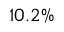Convert formula to latex. <formula><loc_0><loc_0><loc_500><loc_500>1 0 . 2 \%</formula> 